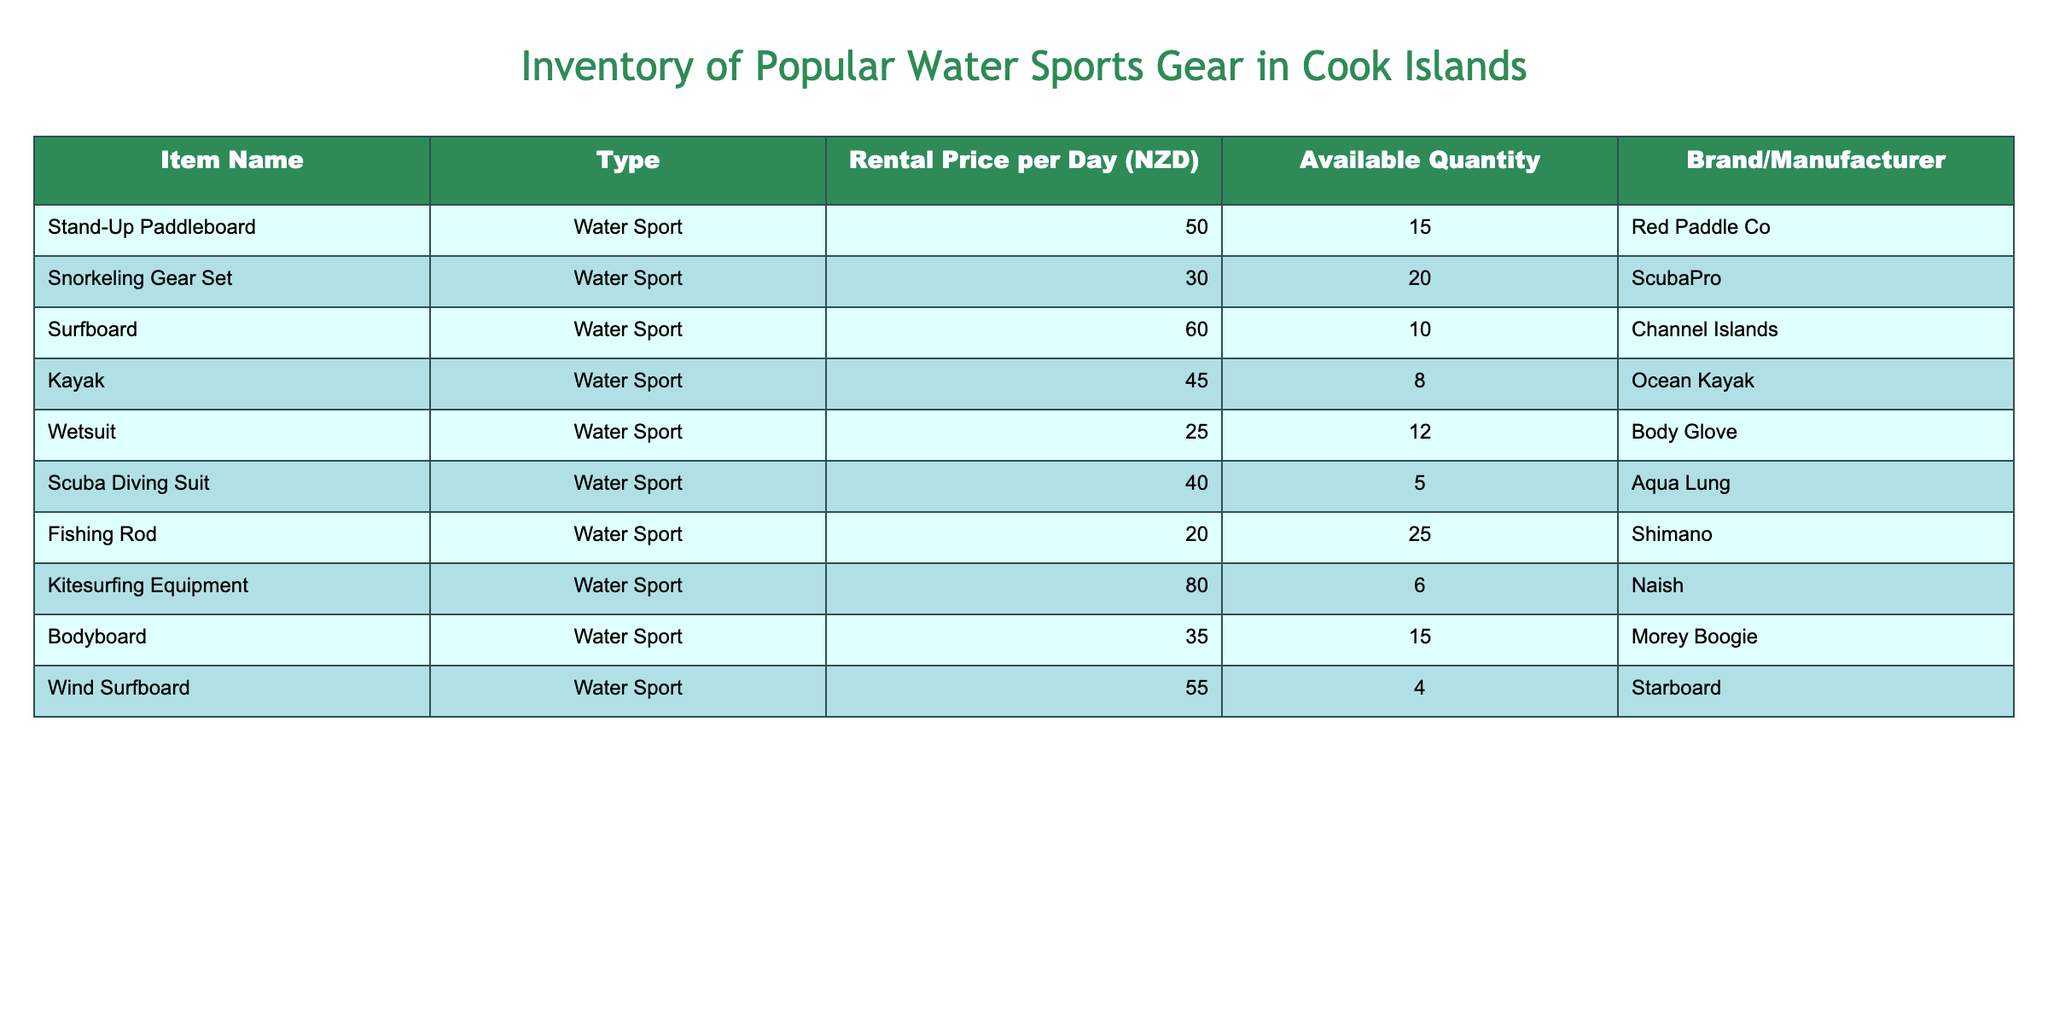What is the rental price per day for a kayak? The kayak's rental price is listed in the table under the "Rental Price per Day (NZD)" column. The value corresponding to the kayak is 45 NZD.
Answer: 45 NZD How many snorkeling gear sets are available for rent? The available quantity of snorkeling gear sets is found in the "Available Quantity" column. It shows there are 20 snorkeling gear sets available.
Answer: 20 Which water sport gear has the highest rental price per day? To identify the gear with the highest rental price, we can compare the values in the "Rental Price per Day (NZD)" column. The kitesurfing equipment is priced at 80 NZD, which is the highest among all items.
Answer: Kitesurfing Equipment Is the quantity of surfboards greater than the quantity of wetsuits? We compare the "Available Quantity" of surfboards (10) and wetsuits (12). Since 10 is less than 12, the statement is false.
Answer: No What is the total rental price per day for all available fishing rods? The total rental price per day for fishing rods is calculated by multiplying the rental price (20 NZD) by the available quantity (25). Therefore, it is 20 * 25 = 500 NZD.
Answer: 500 NZD How much more expensive is a surfboard compared to a wetsuit? We find the rental prices: surfboard (60 NZD) and wetsuit (25 NZD). The difference is calculated as 60 - 25 = 35 NZD, indicating that a surfboard is 35 NZD more expensive than a wetsuit.
Answer: 35 NZD If I want to rent all the kayaks and wind surfboards available, how much would that cost in total? The rental price for a kayak is 45 NZD, and for a wind surfboard, it is 55 NZD. The quantities available are 8 kayaks and 4 wind surfboards. The total cost is calculated as: (45 * 8) + (55 * 4) = 360 + 220 = 580 NZD.
Answer: 580 NZD Are there more stand-up paddleboards available than bodyboards? The available quantity for stand-up paddleboards is 15, and for bodyboards, it is also 15. Since both quantities are equal, the statement is false.
Answer: No What is the average rental price of the water sports gear listed? To find the average rental price, we first need to sum all rental prices: (50 + 30 + 60 + 45 + 25 + 40 + 20 + 80 + 35 + 55) = 440 NZD. There are ten items, so we divide 440 by 10. The average rental price is 440 / 10 = 44 NZD.
Answer: 44 NZD 